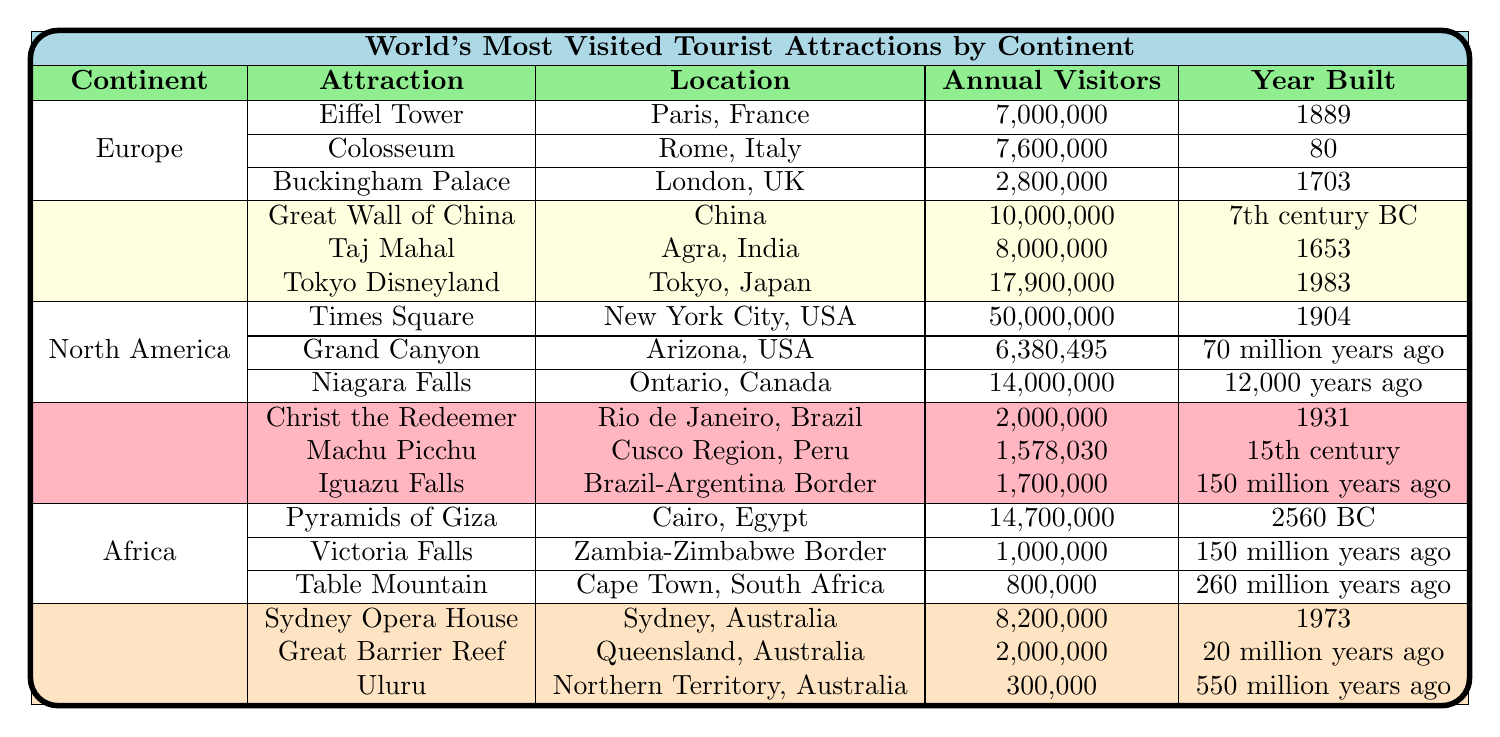What is the most visited attraction in North America? According to the table, Times Square in New York City, USA has the highest annual visitors at 50,000,000 among the attractions listed in North America.
Answer: Times Square How many annual visitors does the Eiffel Tower have? The table indicates that the Eiffel Tower in Paris, France has 7,000,000 annual visitors.
Answer: 7,000,000 Which continent has the least visited attraction and what is it? By comparing annual visitor numbers from the table, Table Mountain in Cape Town, South Africa has the least at 800,000.
Answer: Table Mountain Is the Taj Mahal more visited than the Great Wall of China? The table shows that the Taj Mahal has 8,000,000 annual visitors while the Great Wall of China has 10,000,000, meaning the Taj Mahal is less visited.
Answer: No What is the total number of annual visitors for all attractions in Europe? Adding the annual visitors for European attractions, 7,000,000 (Eiffel Tower) + 7,600,000 (Colosseum) + 2,800,000 (Buckingham Palace) gives a total of 17,400,000.
Answer: 17,400,000 Which attraction was built the earliest and where is it located? The Pyramids of Giza were built in 2560 BC according to the table, making it the earliest built attraction. It is located in Cairo, Egypt.
Answer: Pyramids of Giza in Cairo, Egypt How many more visitors does the Great Wall of China have compared to Christ the Redeemer? The Great Wall of China has 10,000,000 annual visitors and Christ the Redeemer has 2,000,000. The difference (10,000,000 - 2,000,000) is 8,000,000 more visitors.
Answer: 8,000,000 What’s the average number of visitors for Australian attractions? The total visitors for Australian attractions are 8,200,000 (Sydney Opera House) + 2,000,000 (Great Barrier Reef) + 300,000 (Uluru) = 10,500,000. There are 3 attractions so, the average is 10,500,000 / 3 = 3,500,000.
Answer: 3,500,000 Which attraction has the highest number of visitors on the continent of Asia? According to the table, Tokyo Disneyland has the highest number of visitors in Asia with 17,900,000 annual visitors.
Answer: Tokyo Disneyland Are there more visitors to the Grand Canyon or to Niagara Falls? The Grand Canyon has 6,380,495 annual visitors, while Niagara Falls has 14,000,000. Since 14,000,000 is greater than 6,380,495, Niagara Falls has more visitors.
Answer: Niagara Falls has more visitors 